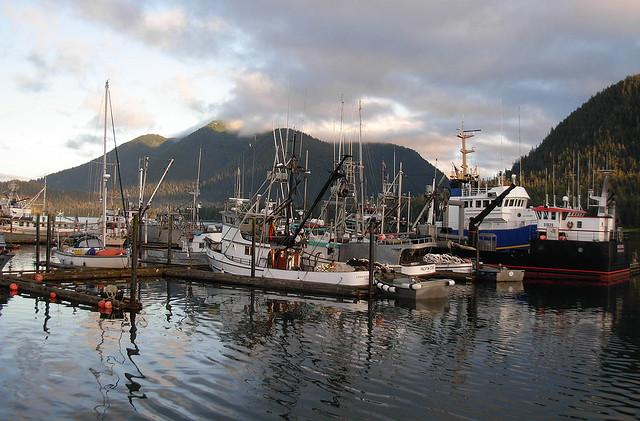What color are the lateral stripes wrapped around the black bodied boat? red 